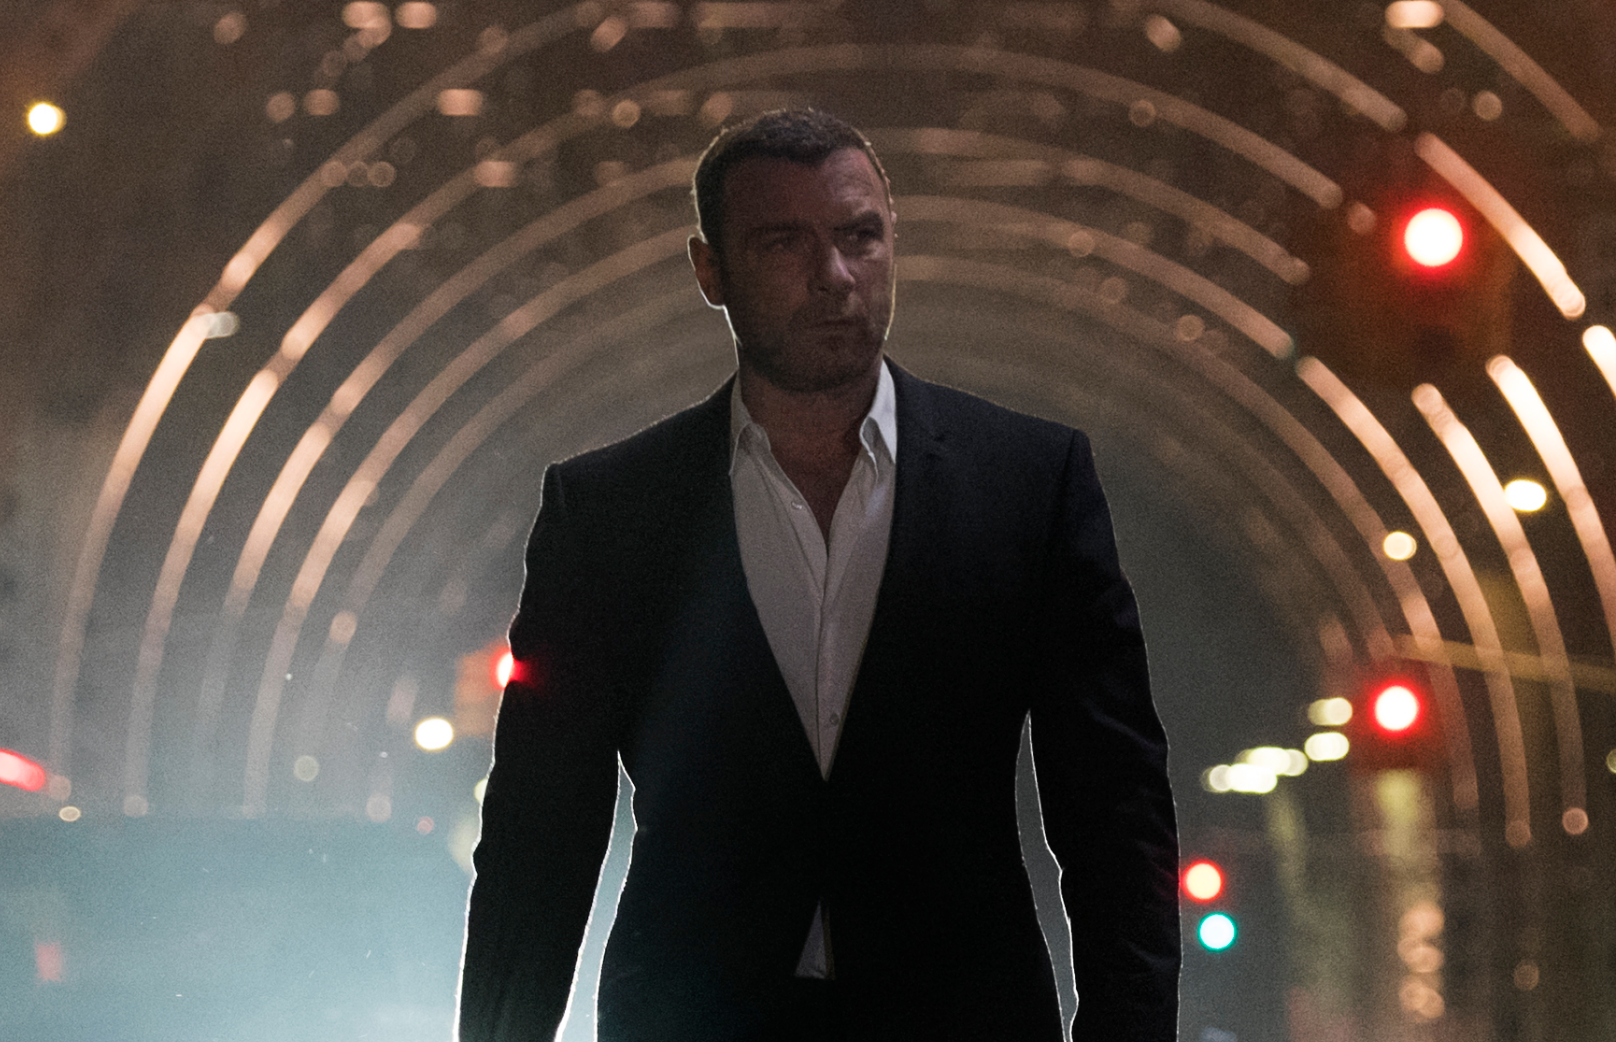What do you think is going on in this snapshot? In the image, we see a figure walking towards the camera with a determined expression. Their attire is a classic black suit paired with a white shirt, which could suggest a formal event or business setting. The scene is set at night with lights creating an interesting tunnel effect around the subject, and the background has a mix of red and green lights, possibly from traffic signals. This could imply an urban setting, maybe the subject's walking from or to an important event or meeting. The overall tone of the picture is moody and cinematic. 